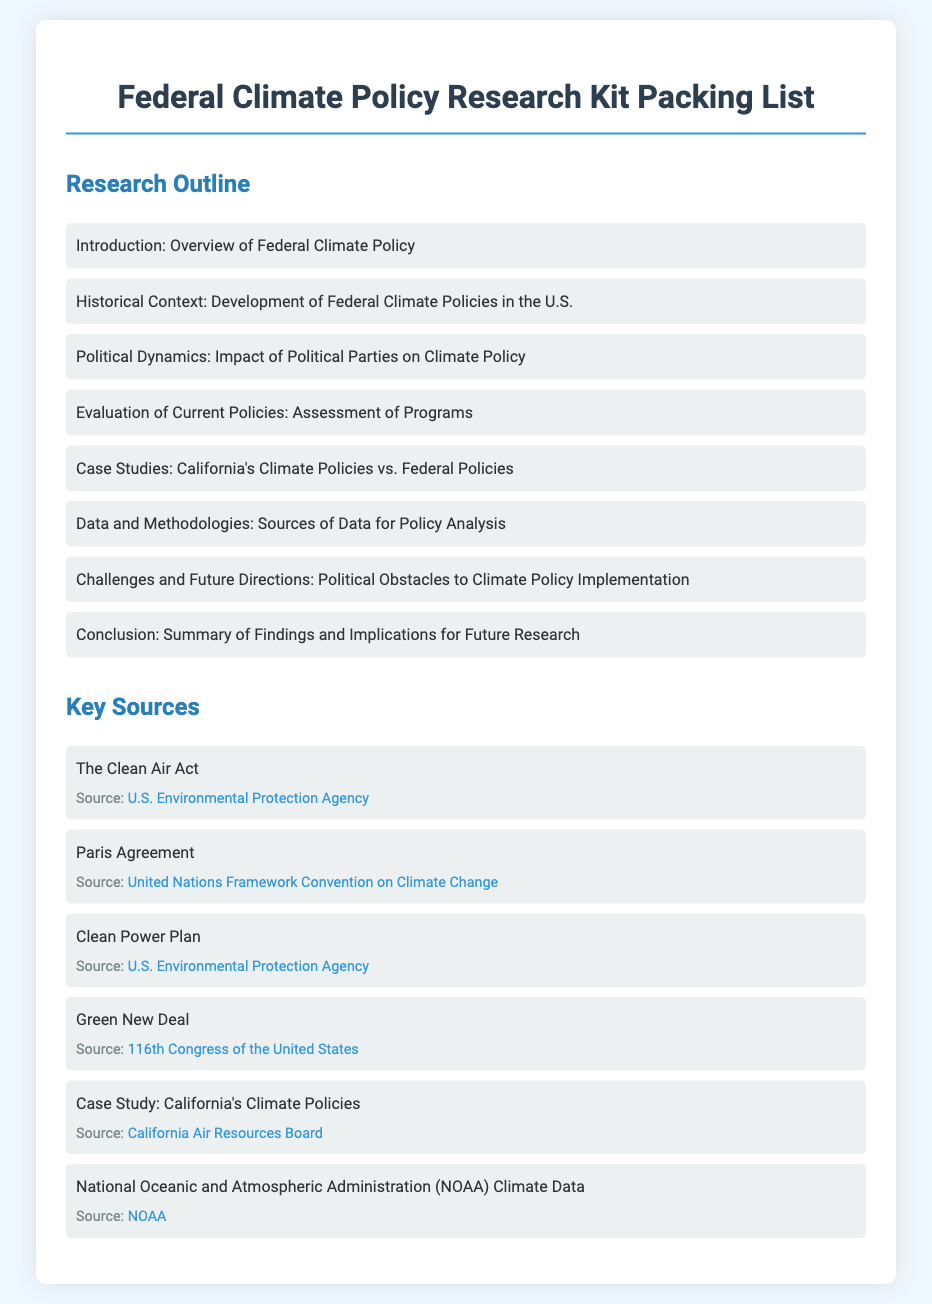What is the title of the document? The title appears at the top of the document and indicates the document's content.
Answer: Federal Climate Policy Research Kit Packing List How many main sections are in the Research Outline? The Research Outline contains a list of topics that represent its sections, which can be counted.
Answer: 8 What is the source for the Clean Air Act? This information can be found in the Key Sources section, providing a specific reference for the Clean Air Act.
Answer: U.S. Environmental Protection Agency Which case study is mentioned in the document? The document lists specific case studies in the Research Outline, which include particular examples of climate policies.
Answer: California's Climate Policies What is the last item in the Key Sources list? The last item in the Key Sources section represents the most recent reference provided in that list.
Answer: National Oceanic and Atmospheric Administration (NOAA) Climate Data What is the main focus of the "Challenges and Future Directions" section? Although the section itself is not detailed in the question, its title suggests a particular aspect of climate policy research.
Answer: Political Obstacles to Climate Policy Implementation 